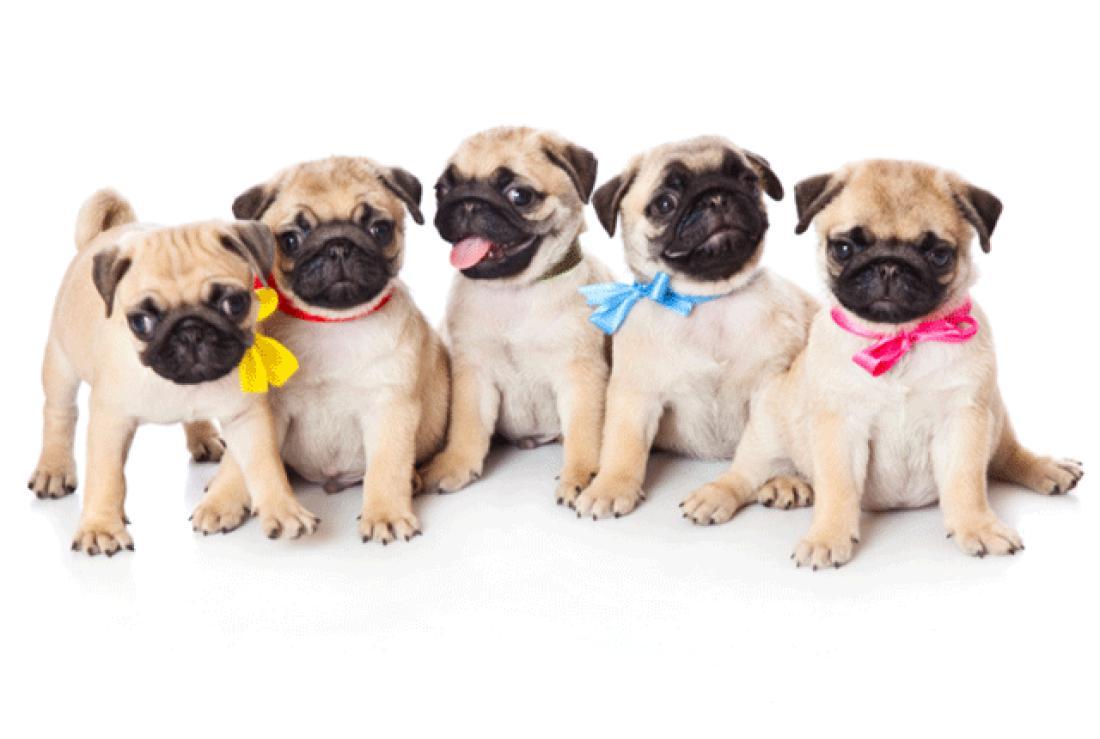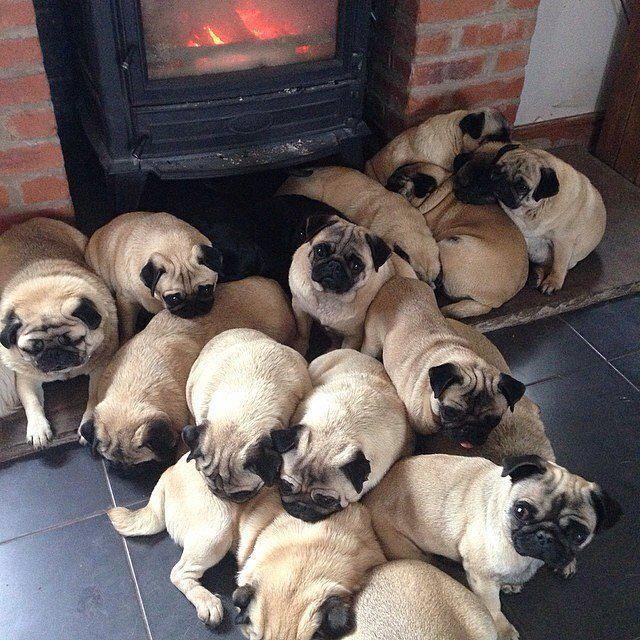The first image is the image on the left, the second image is the image on the right. Examine the images to the left and right. Is the description "there are at least five dogs in the image on the left" accurate? Answer yes or no. Yes. The first image is the image on the left, the second image is the image on the right. Considering the images on both sides, is "There are more pug dogs in the left image than in the right." valid? Answer yes or no. No. The first image is the image on the left, the second image is the image on the right. Given the left and right images, does the statement "One of the paired images shows exactly four pug puppies." hold true? Answer yes or no. No. 